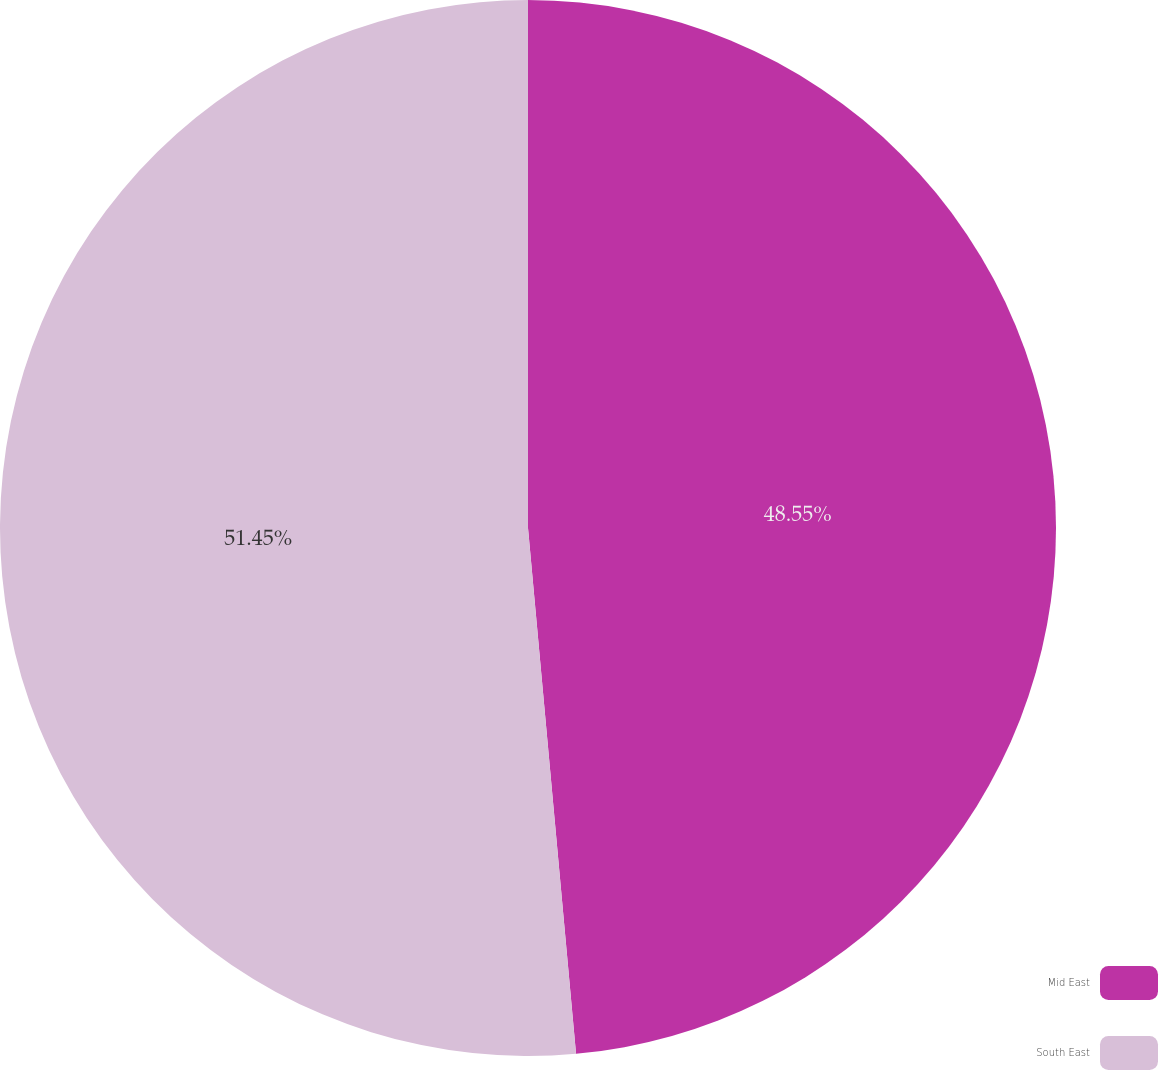Convert chart to OTSL. <chart><loc_0><loc_0><loc_500><loc_500><pie_chart><fcel>Mid East<fcel>South East<nl><fcel>48.55%<fcel>51.45%<nl></chart> 